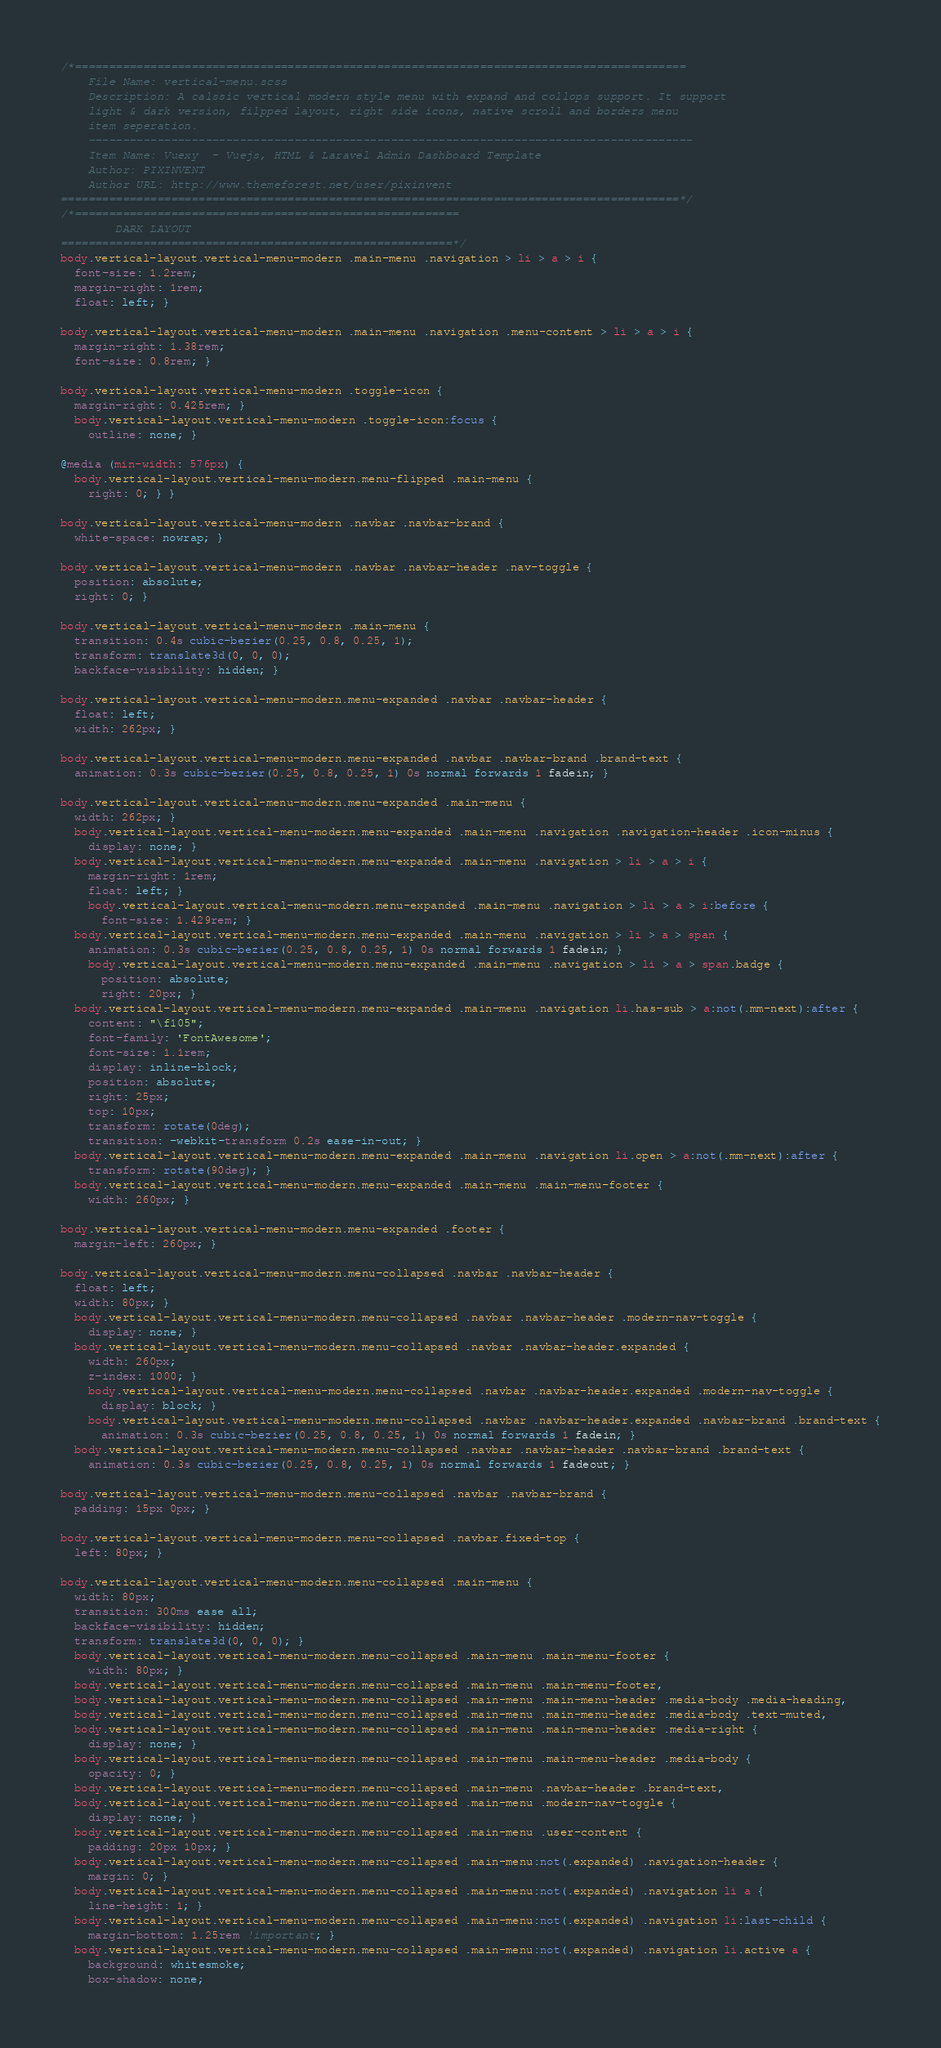Convert code to text. <code><loc_0><loc_0><loc_500><loc_500><_CSS_>/*=========================================================================================
    File Name: vertical-menu.scss
    Description: A calssic vertical modern style menu with expand and collops support. It support
    light & dark version, filpped layout, right side icons, native scroll and borders menu
    item seperation.
    ----------------------------------------------------------------------------------------
    Item Name: Vuexy  - Vuejs, HTML & Laravel Admin Dashboard Template
    Author: PIXINVENT
    Author URL: http://www.themeforest.net/user/pixinvent
==========================================================================================*/
/*========================================================
        DARK LAYOUT
=========================================================*/
body.vertical-layout.vertical-menu-modern .main-menu .navigation > li > a > i {
  font-size: 1.2rem;
  margin-right: 1rem;
  float: left; }

body.vertical-layout.vertical-menu-modern .main-menu .navigation .menu-content > li > a > i {
  margin-right: 1.38rem;
  font-size: 0.8rem; }

body.vertical-layout.vertical-menu-modern .toggle-icon {
  margin-right: 0.425rem; }
  body.vertical-layout.vertical-menu-modern .toggle-icon:focus {
    outline: none; }

@media (min-width: 576px) {
  body.vertical-layout.vertical-menu-modern.menu-flipped .main-menu {
    right: 0; } }

body.vertical-layout.vertical-menu-modern .navbar .navbar-brand {
  white-space: nowrap; }

body.vertical-layout.vertical-menu-modern .navbar .navbar-header .nav-toggle {
  position: absolute;
  right: 0; }

body.vertical-layout.vertical-menu-modern .main-menu {
  transition: 0.4s cubic-bezier(0.25, 0.8, 0.25, 1);
  transform: translate3d(0, 0, 0);
  backface-visibility: hidden; }

body.vertical-layout.vertical-menu-modern.menu-expanded .navbar .navbar-header {
  float: left;
  width: 262px; }

body.vertical-layout.vertical-menu-modern.menu-expanded .navbar .navbar-brand .brand-text {
  animation: 0.3s cubic-bezier(0.25, 0.8, 0.25, 1) 0s normal forwards 1 fadein; }

body.vertical-layout.vertical-menu-modern.menu-expanded .main-menu {
  width: 262px; }
  body.vertical-layout.vertical-menu-modern.menu-expanded .main-menu .navigation .navigation-header .icon-minus {
    display: none; }
  body.vertical-layout.vertical-menu-modern.menu-expanded .main-menu .navigation > li > a > i {
    margin-right: 1rem;
    float: left; }
    body.vertical-layout.vertical-menu-modern.menu-expanded .main-menu .navigation > li > a > i:before {
      font-size: 1.429rem; }
  body.vertical-layout.vertical-menu-modern.menu-expanded .main-menu .navigation > li > a > span {
    animation: 0.3s cubic-bezier(0.25, 0.8, 0.25, 1) 0s normal forwards 1 fadein; }
    body.vertical-layout.vertical-menu-modern.menu-expanded .main-menu .navigation > li > a > span.badge {
      position: absolute;
      right: 20px; }
  body.vertical-layout.vertical-menu-modern.menu-expanded .main-menu .navigation li.has-sub > a:not(.mm-next):after {
    content: "\f105";
    font-family: 'FontAwesome';
    font-size: 1.1rem;
    display: inline-block;
    position: absolute;
    right: 25px;
    top: 10px;
    transform: rotate(0deg);
    transition: -webkit-transform 0.2s ease-in-out; }
  body.vertical-layout.vertical-menu-modern.menu-expanded .main-menu .navigation li.open > a:not(.mm-next):after {
    transform: rotate(90deg); }
  body.vertical-layout.vertical-menu-modern.menu-expanded .main-menu .main-menu-footer {
    width: 260px; }

body.vertical-layout.vertical-menu-modern.menu-expanded .footer {
  margin-left: 260px; }

body.vertical-layout.vertical-menu-modern.menu-collapsed .navbar .navbar-header {
  float: left;
  width: 80px; }
  body.vertical-layout.vertical-menu-modern.menu-collapsed .navbar .navbar-header .modern-nav-toggle {
    display: none; }
  body.vertical-layout.vertical-menu-modern.menu-collapsed .navbar .navbar-header.expanded {
    width: 260px;
    z-index: 1000; }
    body.vertical-layout.vertical-menu-modern.menu-collapsed .navbar .navbar-header.expanded .modern-nav-toggle {
      display: block; }
    body.vertical-layout.vertical-menu-modern.menu-collapsed .navbar .navbar-header.expanded .navbar-brand .brand-text {
      animation: 0.3s cubic-bezier(0.25, 0.8, 0.25, 1) 0s normal forwards 1 fadein; }
  body.vertical-layout.vertical-menu-modern.menu-collapsed .navbar .navbar-header .navbar-brand .brand-text {
    animation: 0.3s cubic-bezier(0.25, 0.8, 0.25, 1) 0s normal forwards 1 fadeout; }

body.vertical-layout.vertical-menu-modern.menu-collapsed .navbar .navbar-brand {
  padding: 15px 0px; }

body.vertical-layout.vertical-menu-modern.menu-collapsed .navbar.fixed-top {
  left: 80px; }

body.vertical-layout.vertical-menu-modern.menu-collapsed .main-menu {
  width: 80px;
  transition: 300ms ease all;
  backface-visibility: hidden;
  transform: translate3d(0, 0, 0); }
  body.vertical-layout.vertical-menu-modern.menu-collapsed .main-menu .main-menu-footer {
    width: 80px; }
  body.vertical-layout.vertical-menu-modern.menu-collapsed .main-menu .main-menu-footer,
  body.vertical-layout.vertical-menu-modern.menu-collapsed .main-menu .main-menu-header .media-body .media-heading,
  body.vertical-layout.vertical-menu-modern.menu-collapsed .main-menu .main-menu-header .media-body .text-muted,
  body.vertical-layout.vertical-menu-modern.menu-collapsed .main-menu .main-menu-header .media-right {
    display: none; }
  body.vertical-layout.vertical-menu-modern.menu-collapsed .main-menu .main-menu-header .media-body {
    opacity: 0; }
  body.vertical-layout.vertical-menu-modern.menu-collapsed .main-menu .navbar-header .brand-text,
  body.vertical-layout.vertical-menu-modern.menu-collapsed .main-menu .modern-nav-toggle {
    display: none; }
  body.vertical-layout.vertical-menu-modern.menu-collapsed .main-menu .user-content {
    padding: 20px 10px; }
  body.vertical-layout.vertical-menu-modern.menu-collapsed .main-menu:not(.expanded) .navigation-header {
    margin: 0; }
  body.vertical-layout.vertical-menu-modern.menu-collapsed .main-menu:not(.expanded) .navigation li a {
    line-height: 1; }
  body.vertical-layout.vertical-menu-modern.menu-collapsed .main-menu:not(.expanded) .navigation li:last-child {
    margin-bottom: 1.25rem !important; }
  body.vertical-layout.vertical-menu-modern.menu-collapsed .main-menu:not(.expanded) .navigation li.active a {
    background: whitesmoke;
    box-shadow: none;</code> 